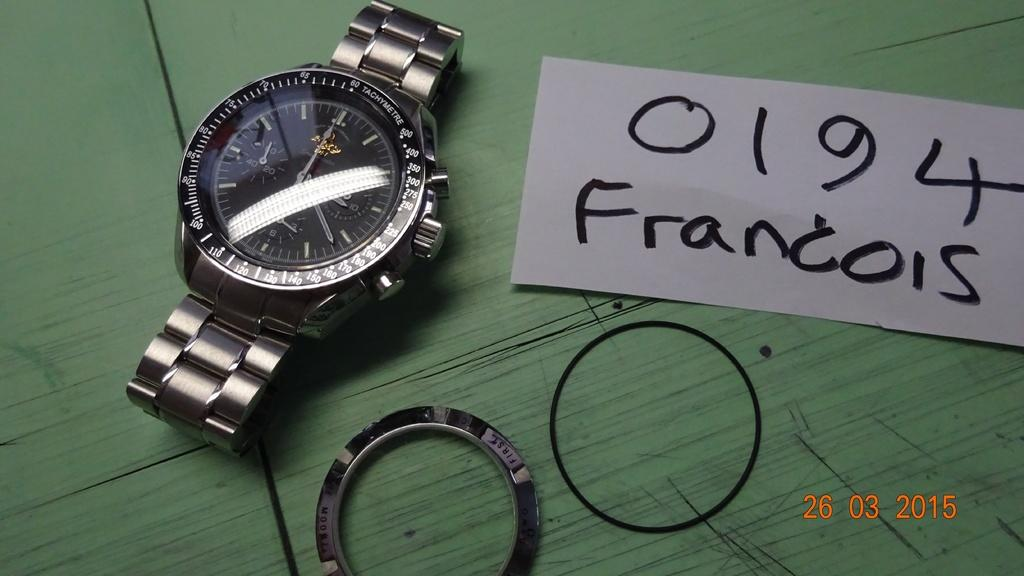<image>
Present a compact description of the photo's key features. 0194 Francois is written in black on a white paper. 